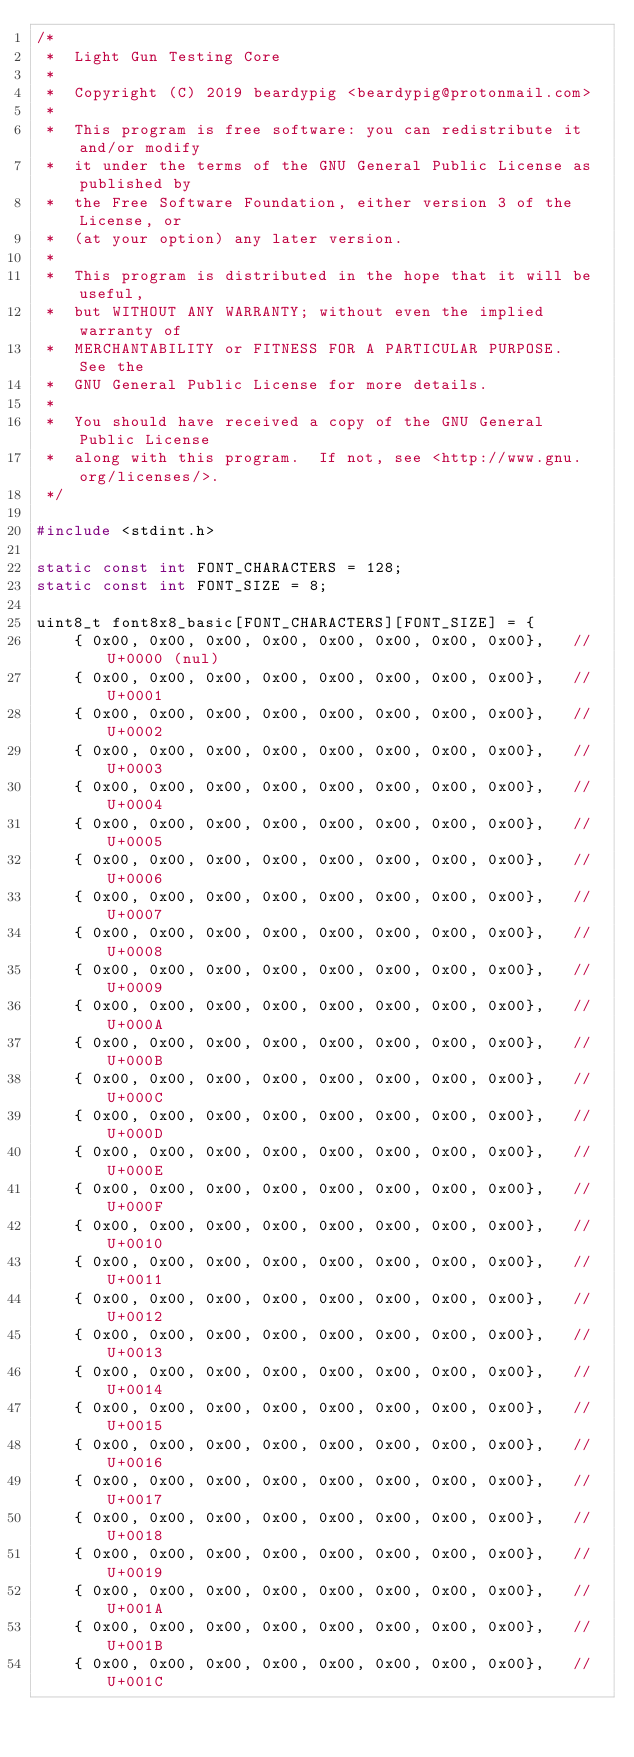<code> <loc_0><loc_0><loc_500><loc_500><_C++_>/*
 *  Light Gun Testing Core
 *
 *  Copyright (C) 2019 beardypig <beardypig@protonmail.com>
 *
 *  This program is free software: you can redistribute it and/or modify
 *  it under the terms of the GNU General Public License as published by
 *  the Free Software Foundation, either version 3 of the License, or
 *  (at your option) any later version.
 *
 *  This program is distributed in the hope that it will be useful,
 *  but WITHOUT ANY WARRANTY; without even the implied warranty of
 *  MERCHANTABILITY or FITNESS FOR A PARTICULAR PURPOSE.  See the
 *  GNU General Public License for more details.
 *
 *  You should have received a copy of the GNU General Public License
 *  along with this program.  If not, see <http://www.gnu.org/licenses/>.
 */

#include <stdint.h>

static const int FONT_CHARACTERS = 128;
static const int FONT_SIZE = 8;

uint8_t font8x8_basic[FONT_CHARACTERS][FONT_SIZE] = {
    { 0x00, 0x00, 0x00, 0x00, 0x00, 0x00, 0x00, 0x00},   // U+0000 (nul)
    { 0x00, 0x00, 0x00, 0x00, 0x00, 0x00, 0x00, 0x00},   // U+0001
    { 0x00, 0x00, 0x00, 0x00, 0x00, 0x00, 0x00, 0x00},   // U+0002
    { 0x00, 0x00, 0x00, 0x00, 0x00, 0x00, 0x00, 0x00},   // U+0003
    { 0x00, 0x00, 0x00, 0x00, 0x00, 0x00, 0x00, 0x00},   // U+0004
    { 0x00, 0x00, 0x00, 0x00, 0x00, 0x00, 0x00, 0x00},   // U+0005
    { 0x00, 0x00, 0x00, 0x00, 0x00, 0x00, 0x00, 0x00},   // U+0006
    { 0x00, 0x00, 0x00, 0x00, 0x00, 0x00, 0x00, 0x00},   // U+0007
    { 0x00, 0x00, 0x00, 0x00, 0x00, 0x00, 0x00, 0x00},   // U+0008
    { 0x00, 0x00, 0x00, 0x00, 0x00, 0x00, 0x00, 0x00},   // U+0009
    { 0x00, 0x00, 0x00, 0x00, 0x00, 0x00, 0x00, 0x00},   // U+000A
    { 0x00, 0x00, 0x00, 0x00, 0x00, 0x00, 0x00, 0x00},   // U+000B
    { 0x00, 0x00, 0x00, 0x00, 0x00, 0x00, 0x00, 0x00},   // U+000C
    { 0x00, 0x00, 0x00, 0x00, 0x00, 0x00, 0x00, 0x00},   // U+000D
    { 0x00, 0x00, 0x00, 0x00, 0x00, 0x00, 0x00, 0x00},   // U+000E
    { 0x00, 0x00, 0x00, 0x00, 0x00, 0x00, 0x00, 0x00},   // U+000F
    { 0x00, 0x00, 0x00, 0x00, 0x00, 0x00, 0x00, 0x00},   // U+0010
    { 0x00, 0x00, 0x00, 0x00, 0x00, 0x00, 0x00, 0x00},   // U+0011
    { 0x00, 0x00, 0x00, 0x00, 0x00, 0x00, 0x00, 0x00},   // U+0012
    { 0x00, 0x00, 0x00, 0x00, 0x00, 0x00, 0x00, 0x00},   // U+0013
    { 0x00, 0x00, 0x00, 0x00, 0x00, 0x00, 0x00, 0x00},   // U+0014
    { 0x00, 0x00, 0x00, 0x00, 0x00, 0x00, 0x00, 0x00},   // U+0015
    { 0x00, 0x00, 0x00, 0x00, 0x00, 0x00, 0x00, 0x00},   // U+0016
    { 0x00, 0x00, 0x00, 0x00, 0x00, 0x00, 0x00, 0x00},   // U+0017
    { 0x00, 0x00, 0x00, 0x00, 0x00, 0x00, 0x00, 0x00},   // U+0018
    { 0x00, 0x00, 0x00, 0x00, 0x00, 0x00, 0x00, 0x00},   // U+0019
    { 0x00, 0x00, 0x00, 0x00, 0x00, 0x00, 0x00, 0x00},   // U+001A
    { 0x00, 0x00, 0x00, 0x00, 0x00, 0x00, 0x00, 0x00},   // U+001B
    { 0x00, 0x00, 0x00, 0x00, 0x00, 0x00, 0x00, 0x00},   // U+001C</code> 